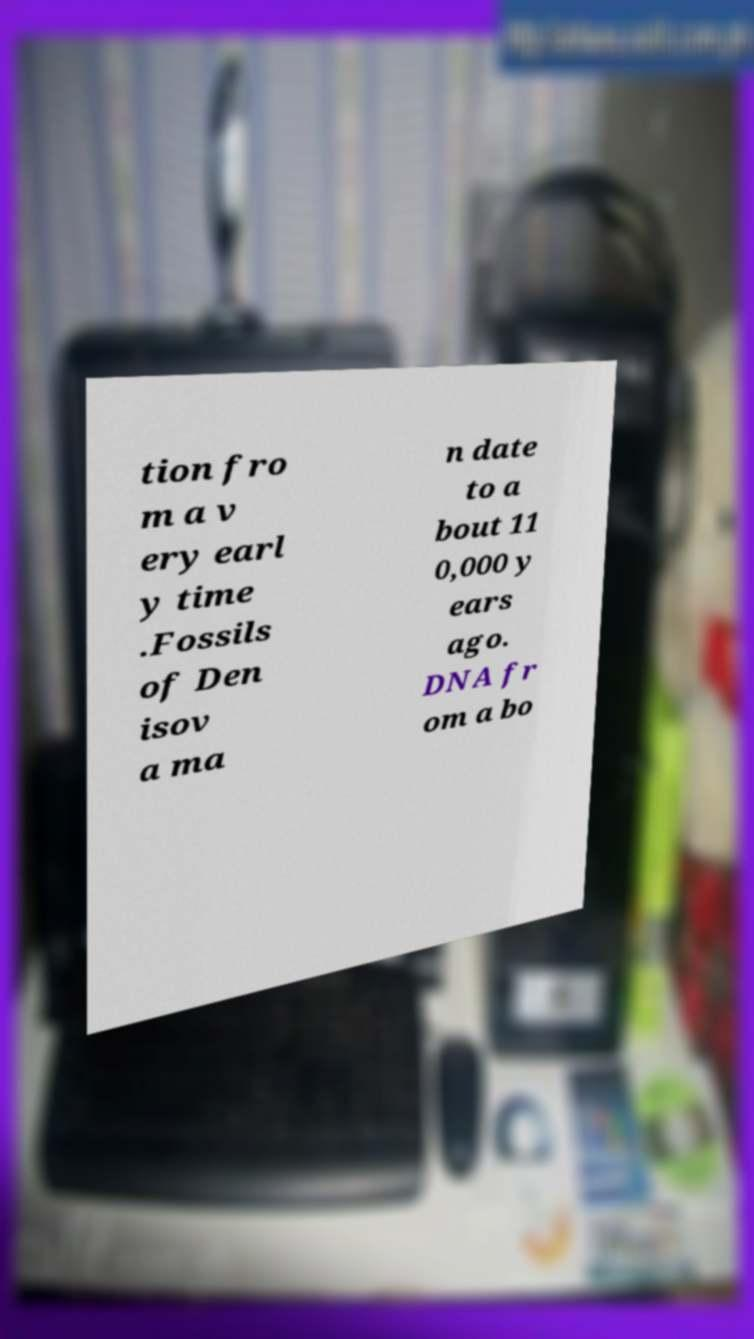What messages or text are displayed in this image? I need them in a readable, typed format. tion fro m a v ery earl y time .Fossils of Den isov a ma n date to a bout 11 0,000 y ears ago. DNA fr om a bo 